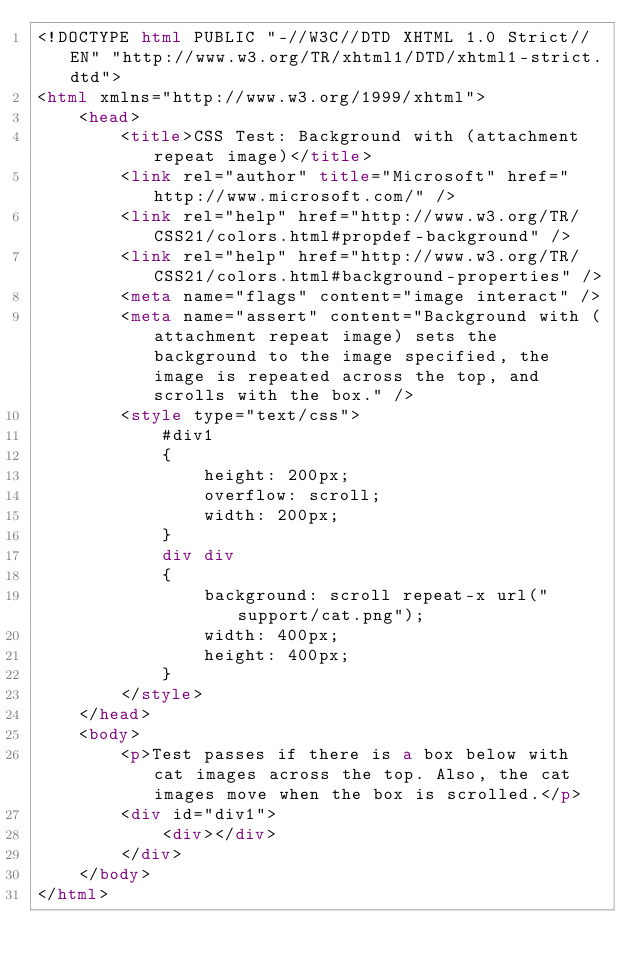Convert code to text. <code><loc_0><loc_0><loc_500><loc_500><_HTML_><!DOCTYPE html PUBLIC "-//W3C//DTD XHTML 1.0 Strict//EN" "http://www.w3.org/TR/xhtml1/DTD/xhtml1-strict.dtd">
<html xmlns="http://www.w3.org/1999/xhtml">
    <head>
        <title>CSS Test: Background with (attachment repeat image)</title>
        <link rel="author" title="Microsoft" href="http://www.microsoft.com/" />
        <link rel="help" href="http://www.w3.org/TR/CSS21/colors.html#propdef-background" />
        <link rel="help" href="http://www.w3.org/TR/CSS21/colors.html#background-properties" />
        <meta name="flags" content="image interact" />
        <meta name="assert" content="Background with (attachment repeat image) sets the background to the image specified, the image is repeated across the top, and scrolls with the box." />
        <style type="text/css">
            #div1
            {
                height: 200px;
                overflow: scroll;
                width: 200px;
            }
            div div
            {
                background: scroll repeat-x url("support/cat.png");
                width: 400px;
                height: 400px;
            }
        </style>
    </head>
    <body>
        <p>Test passes if there is a box below with cat images across the top. Also, the cat images move when the box is scrolled.</p>
        <div id="div1">
            <div></div>
        </div>
    </body>
</html></code> 